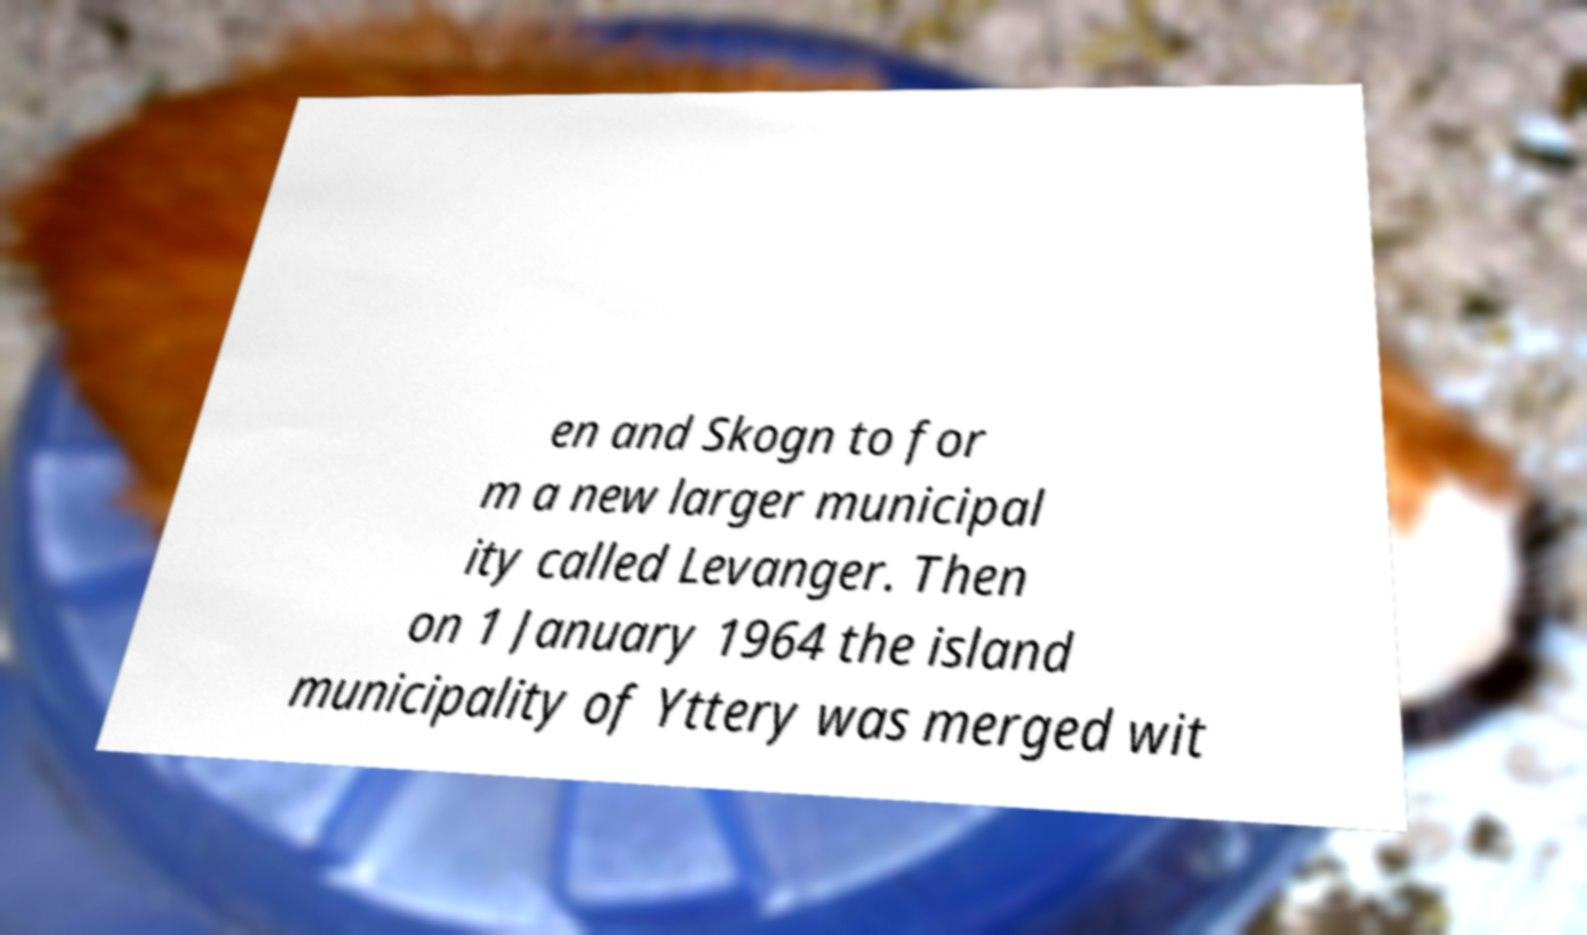For documentation purposes, I need the text within this image transcribed. Could you provide that? en and Skogn to for m a new larger municipal ity called Levanger. Then on 1 January 1964 the island municipality of Yttery was merged wit 